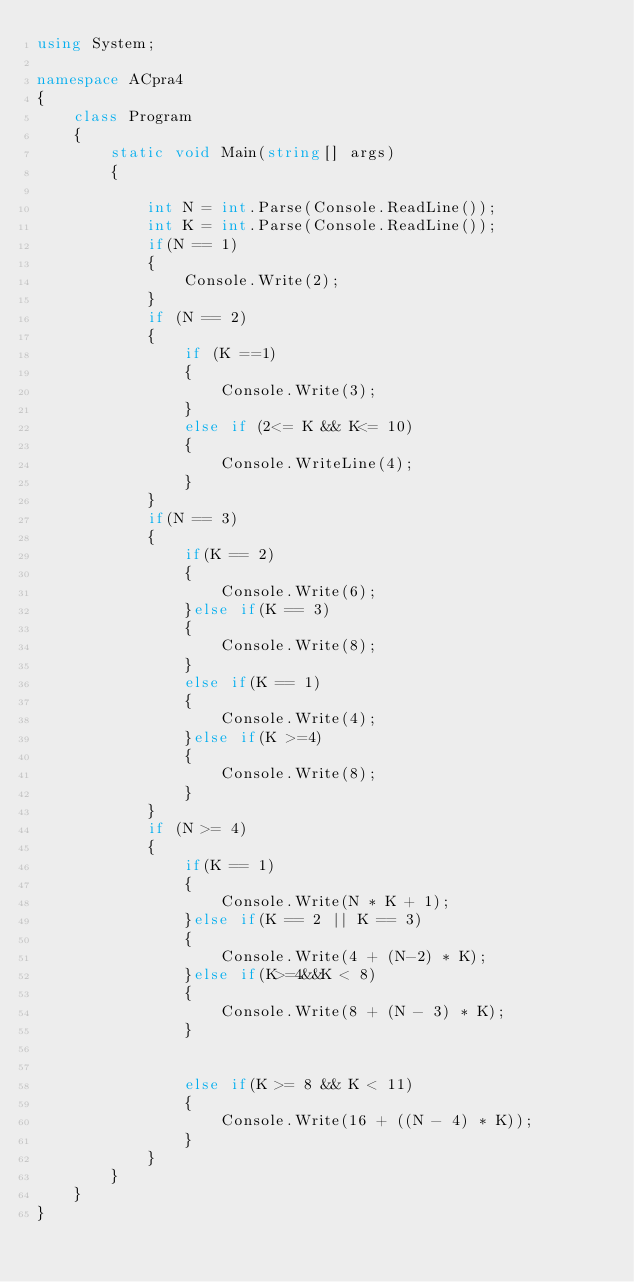Convert code to text. <code><loc_0><loc_0><loc_500><loc_500><_C#_>using System;

namespace ACpra4
{
    class Program
    {
        static void Main(string[] args)
        {

            int N = int.Parse(Console.ReadLine());
            int K = int.Parse(Console.ReadLine());
            if(N == 1)
            {
                Console.Write(2);   
            }
            if (N == 2)
            {
                if (K ==1)
                {
                    Console.Write(3);
                }
                else if (2<= K && K<= 10)
                {
                    Console.WriteLine(4);
                }
            }
            if(N == 3)
            {
                if(K == 2)
                {
                    Console.Write(6);
                }else if(K == 3)
                {
                    Console.Write(8);
                }
                else if(K == 1)
                {
                    Console.Write(4);
                }else if(K >=4)
                {
                    Console.Write(8);
                }
            }
            if (N >= 4)
            {
                if(K == 1)
                {
                    Console.Write(N * K + 1);
                }else if(K == 2 || K == 3)
                {
                    Console.Write(4 + (N-2) * K);
                }else if(K>=4&&K < 8)
                {
                    Console.Write(8 + (N - 3) * K);
                }
             
                
                else if(K >= 8 && K < 11)
                { 
                    Console.Write(16 + ((N - 4) * K));
                }
            }
        }
    }
}</code> 